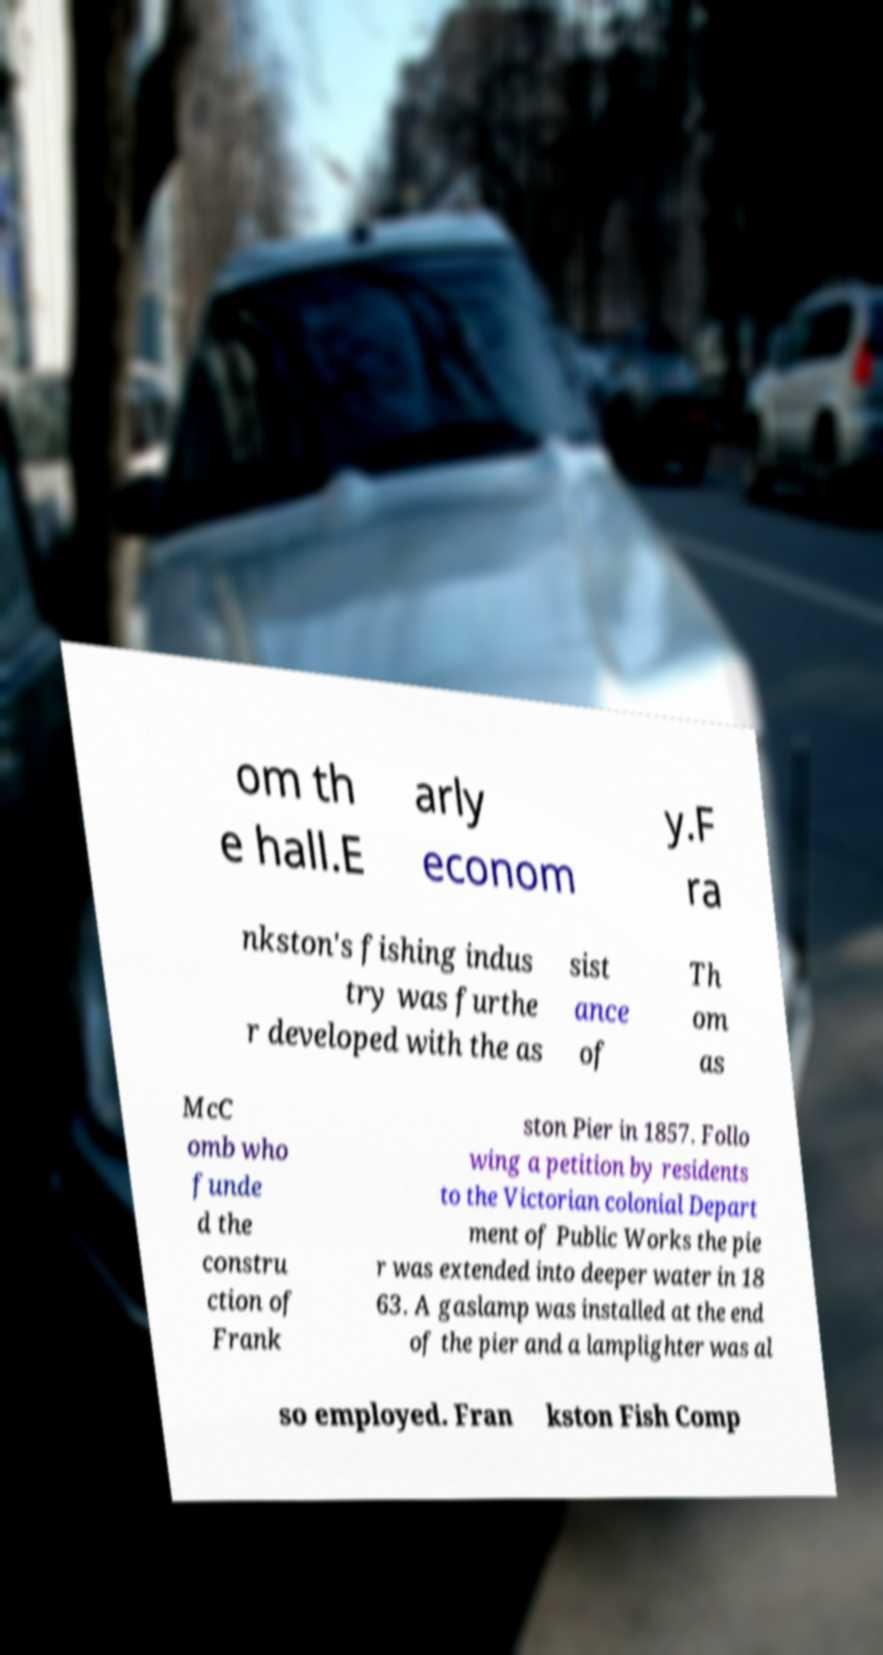For documentation purposes, I need the text within this image transcribed. Could you provide that? om th e hall.E arly econom y.F ra nkston's fishing indus try was furthe r developed with the as sist ance of Th om as McC omb who funde d the constru ction of Frank ston Pier in 1857. Follo wing a petition by residents to the Victorian colonial Depart ment of Public Works the pie r was extended into deeper water in 18 63. A gaslamp was installed at the end of the pier and a lamplighter was al so employed. Fran kston Fish Comp 